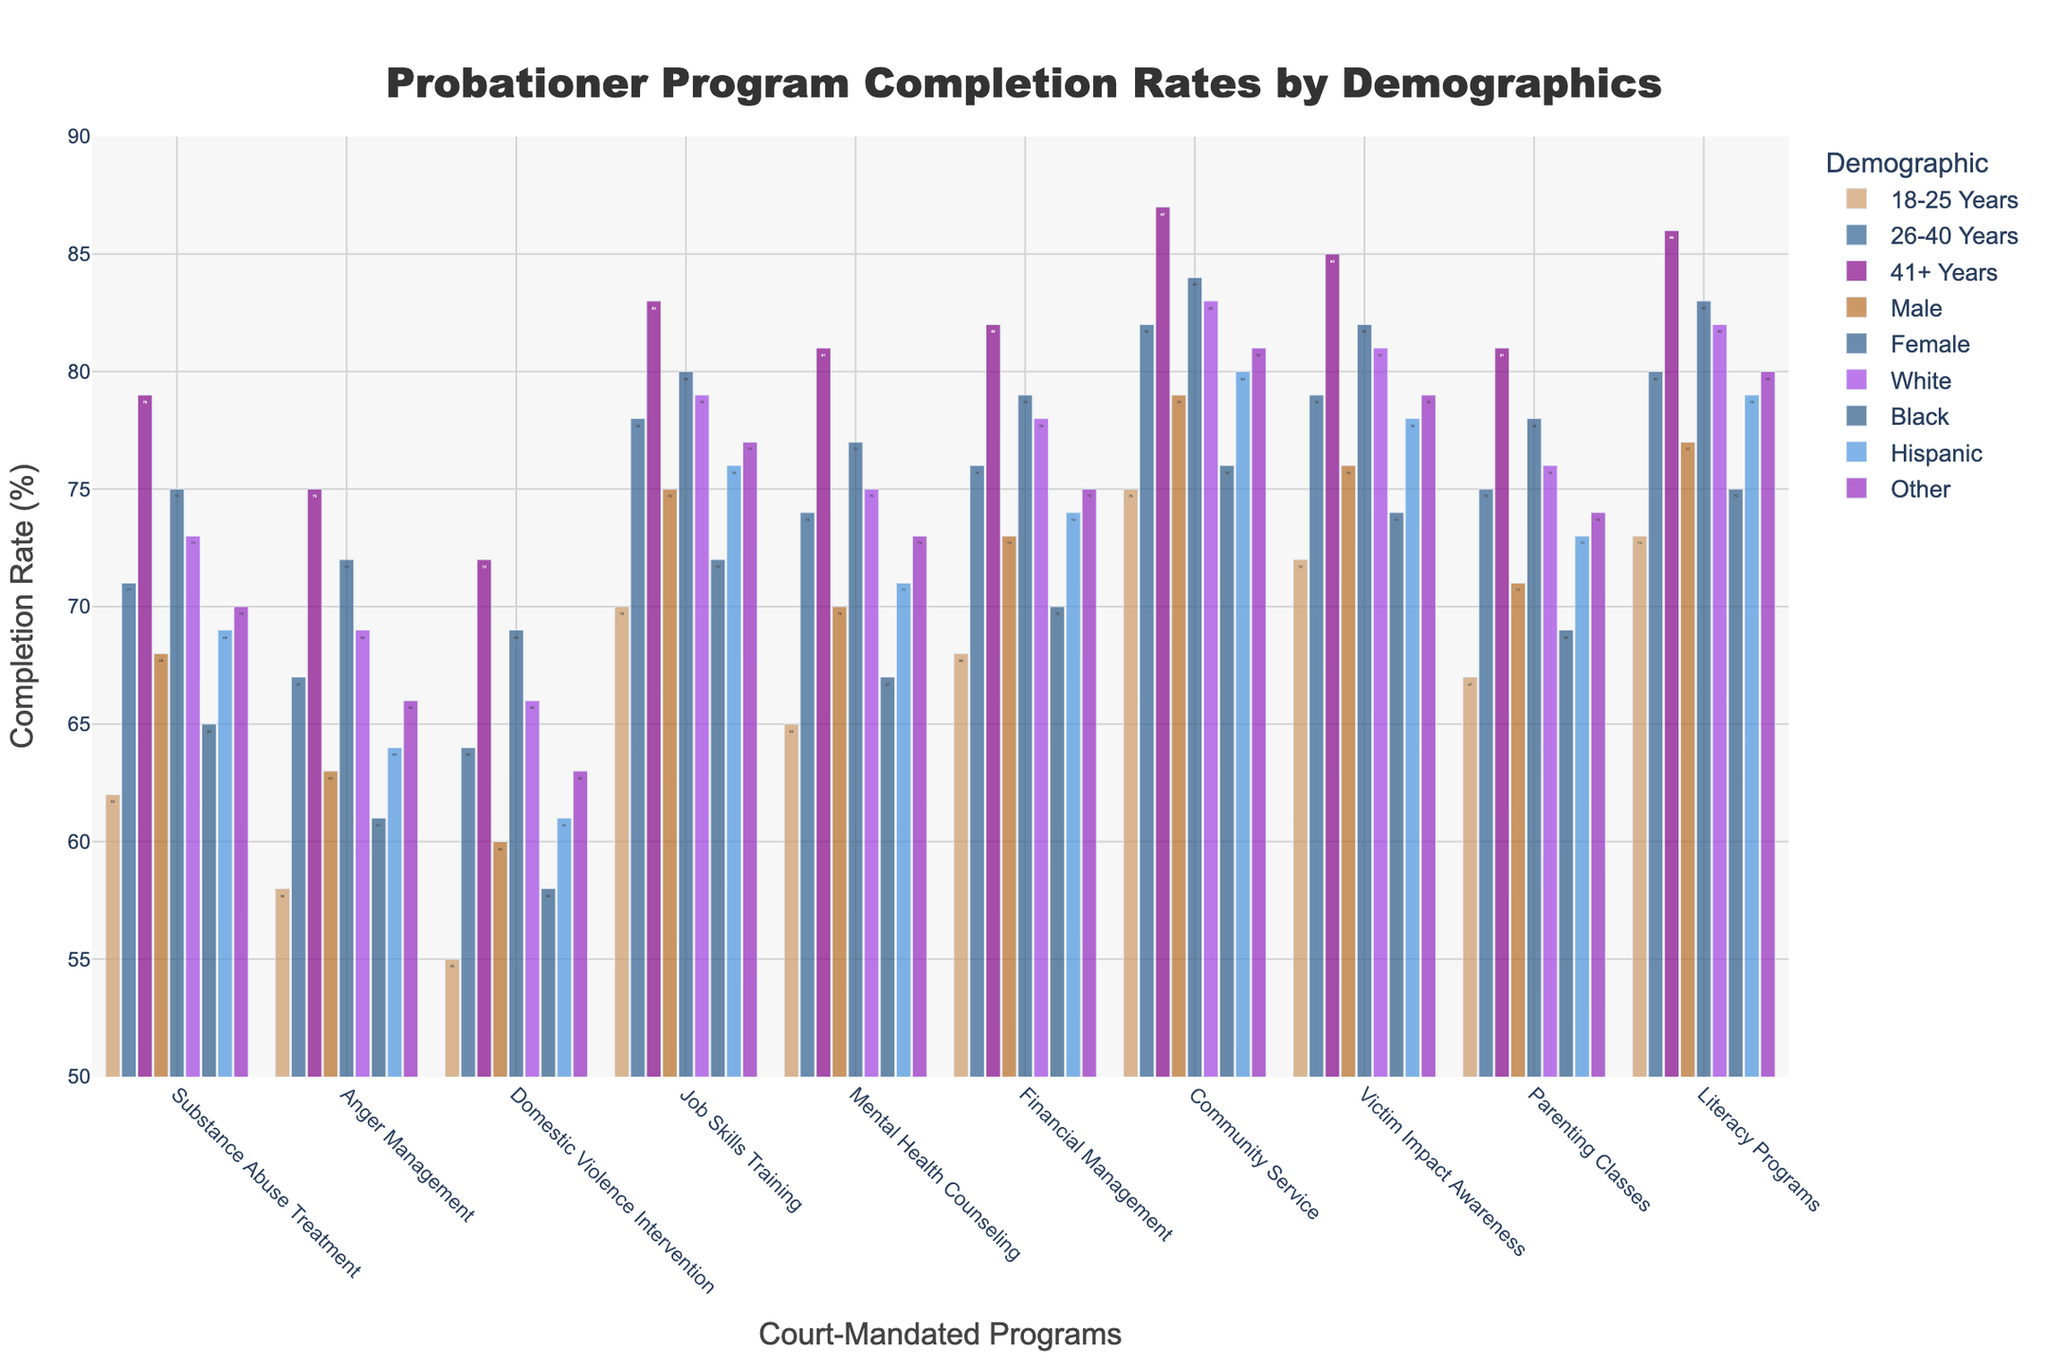What's the highest completion rate among the demographic groups for the Substance Abuse Treatment program? Look for the tallest bar corresponding to the Substance Abuse Treatment program. The highest completion rate is 79%, which belongs to the "41+ Years" group.
Answer: 79% Which demographic group has the lowest completion rate for the Domestic Violence Intervention program? Look for the shortest bar corresponding to the Domestic Violence Intervention program. The "Black" group has the lowest completion rate at 58%.
Answer: Black Compare the completion rates of the Community Service program between males and females. Which group has a higher rate and by how much? Find the heights of the bars for males and females in the Community Service program. Males have a completion rate of 79% and females have 84%, so females have a 5% higher rate.
Answer: Females by 5% What’s the average completion rate of the Mental Health Counseling program across all demographic groups for age? Add the completion rates for the "18-25 Years," "26-40 Years," and "41+ Years" groups and divide by 3: (65 + 74 + 81)/3 = 73.33%.
Answer: 73.33% What's the difference in completion rates between the Job Skills Training program for Whites and Hispanics? Find the heights of the bars for Whites and Hispanics in the Job Skills Training program. Whites have a completion rate of 79% and Hispanics have 76%, so the difference is 3%.
Answer: 3% Which demographic has the most consistent range of completion rates across all programs? Examine the range of completion rates for each demographic group across all programs. The "41+ Years" group has consistently high rates, ranging from 72% to 87%, indicating a high level of consistency.
Answer: 41+ Years For the Literacy Programs, which demographic group has the highest completion rate? Look at the tallest bar for the Literacy Programs. The "41+ Years" group has the highest completion rate at 86%.
Answer: 41+ Years Compare the completion rates of Parenting Classes for Hispanics and Blacks. Which group has the higher rate and by how much? Find the heights of the bars for Hispanics and Blacks in the Parenting Classes program. Hispanics have a completion rate of 73% and Blacks have 69%, so Hispanics have a 4% higher rate.
Answer: Hispanics by 4% What is the median completion rate of the Financial Management program across all demographics? List all the completion rates for the Financial Management program, which are 68, 76, 82, 73, 79, 78, 70, 74, 75. The median value, when arranged in order (68, 70, 73, 74, 75, 76, 78, 79, 82), is the middle value 75%.
Answer: 75% What’s the difference between the highest and lowest completion rates for the Anger Management program? Identify the highest and lowest bars for Anger Management. The highest is 75% ("41+ Years") and the lowest is 58% ("18-25 Years"). The difference is 75% - 58% = 17%.
Answer: 17% 